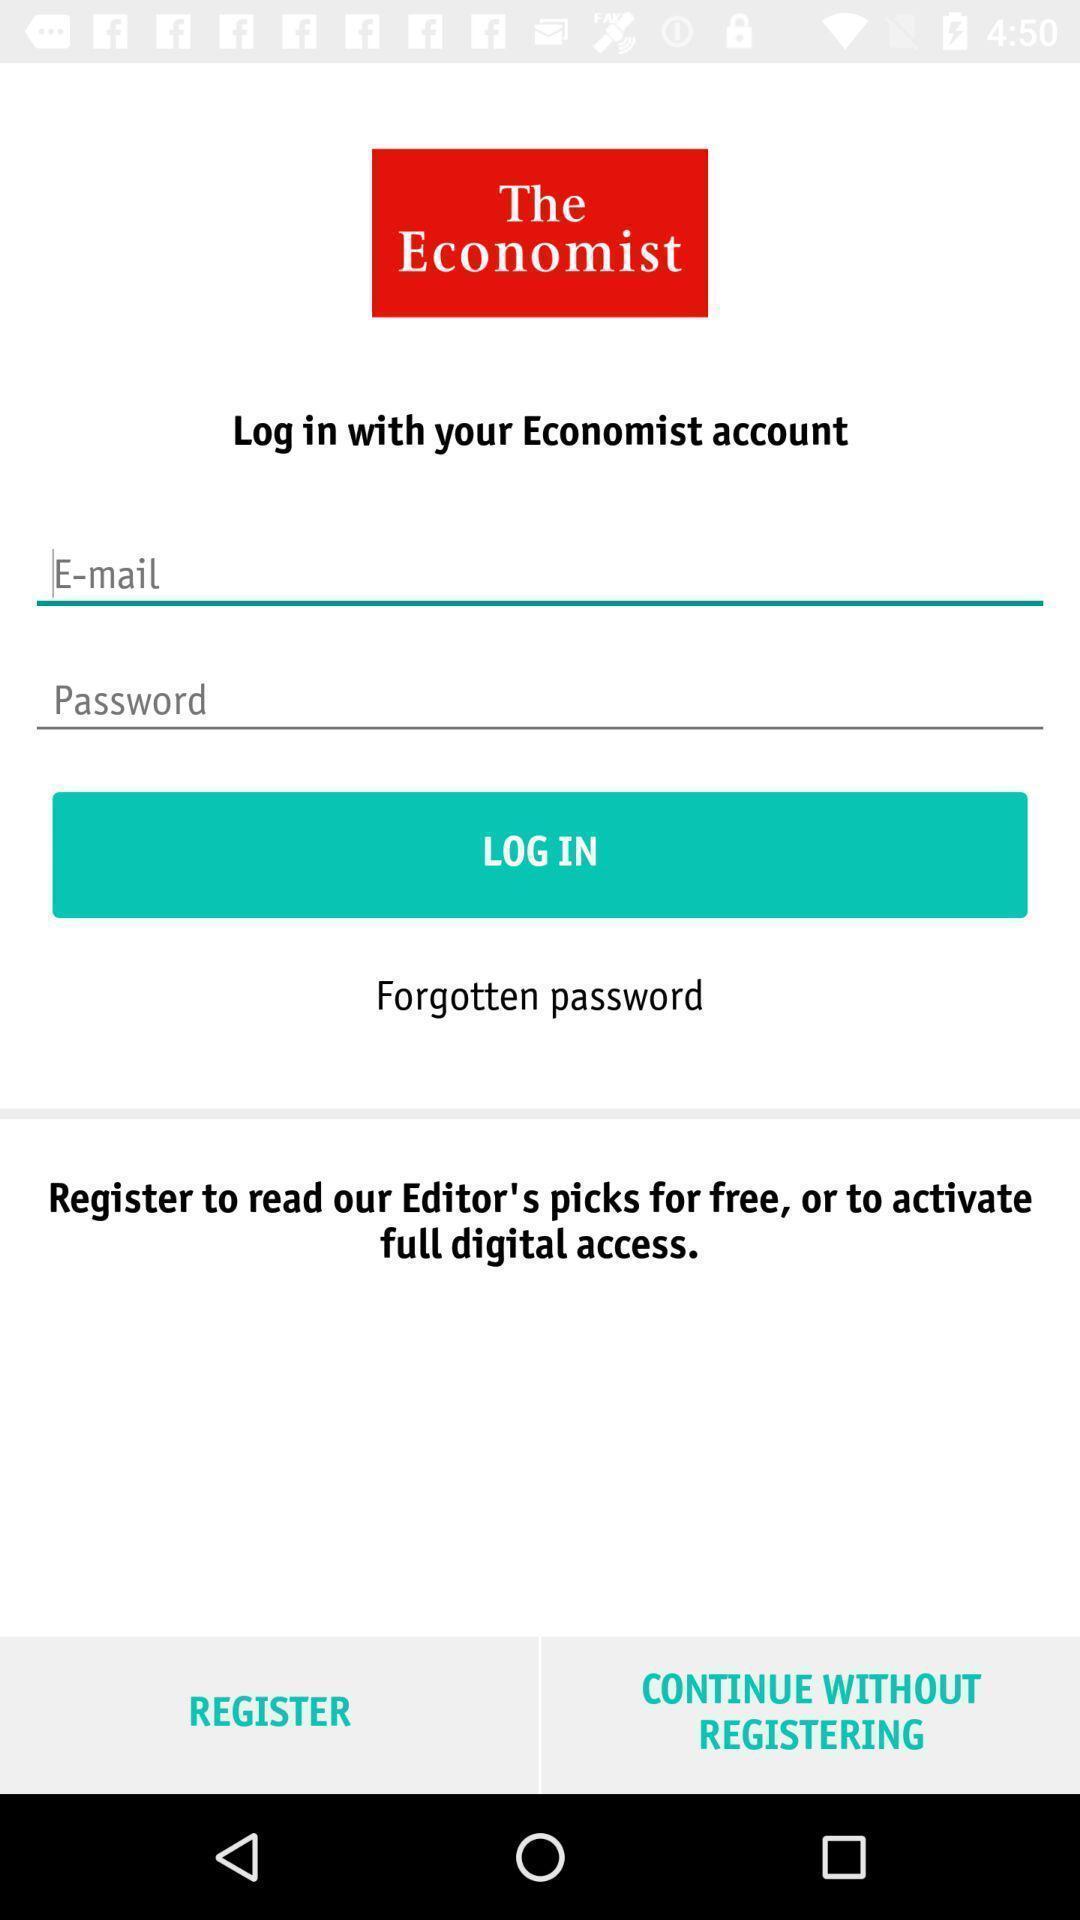Please provide a description for this image. Page displaying signing in information. 